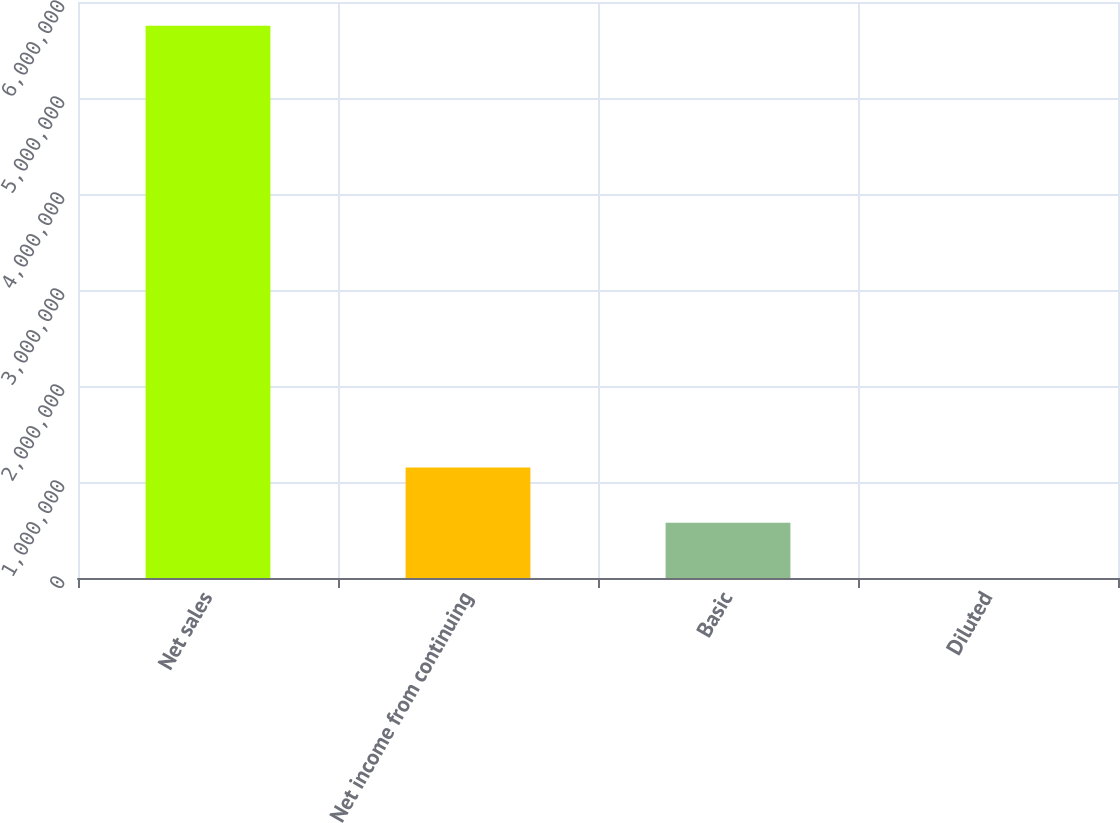Convert chart to OTSL. <chart><loc_0><loc_0><loc_500><loc_500><bar_chart><fcel>Net sales<fcel>Net income from continuing<fcel>Basic<fcel>Diluted<nl><fcel>5.75371e+06<fcel>1.15074e+06<fcel>575372<fcel>1.07<nl></chart> 